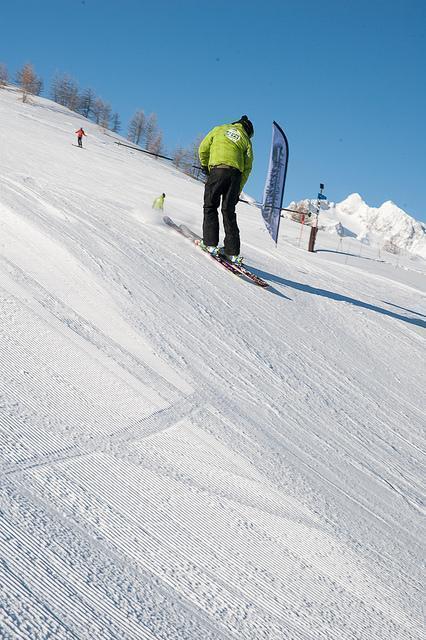What is this sport name?
Answer the question by selecting the correct answer among the 4 following choices and explain your choice with a short sentence. The answer should be formatted with the following format: `Answer: choice
Rationale: rationale.`
Options: Swimming, skiing, sky diving, skating. Answer: skiing.
Rationale: The people are on snow and are not using skates. 